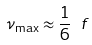Convert formula to latex. <formula><loc_0><loc_0><loc_500><loc_500>\nu _ { \max } \approx \frac { 1 } { 6 } \ f</formula> 